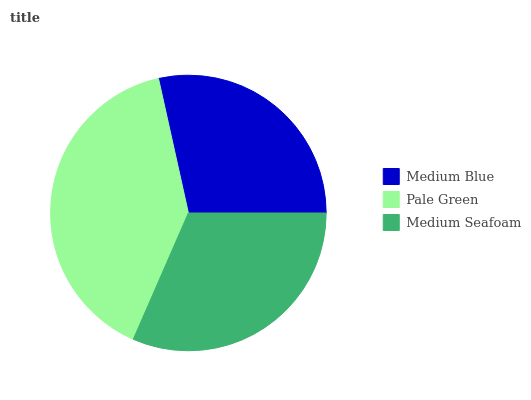Is Medium Blue the minimum?
Answer yes or no. Yes. Is Pale Green the maximum?
Answer yes or no. Yes. Is Medium Seafoam the minimum?
Answer yes or no. No. Is Medium Seafoam the maximum?
Answer yes or no. No. Is Pale Green greater than Medium Seafoam?
Answer yes or no. Yes. Is Medium Seafoam less than Pale Green?
Answer yes or no. Yes. Is Medium Seafoam greater than Pale Green?
Answer yes or no. No. Is Pale Green less than Medium Seafoam?
Answer yes or no. No. Is Medium Seafoam the high median?
Answer yes or no. Yes. Is Medium Seafoam the low median?
Answer yes or no. Yes. Is Pale Green the high median?
Answer yes or no. No. Is Pale Green the low median?
Answer yes or no. No. 